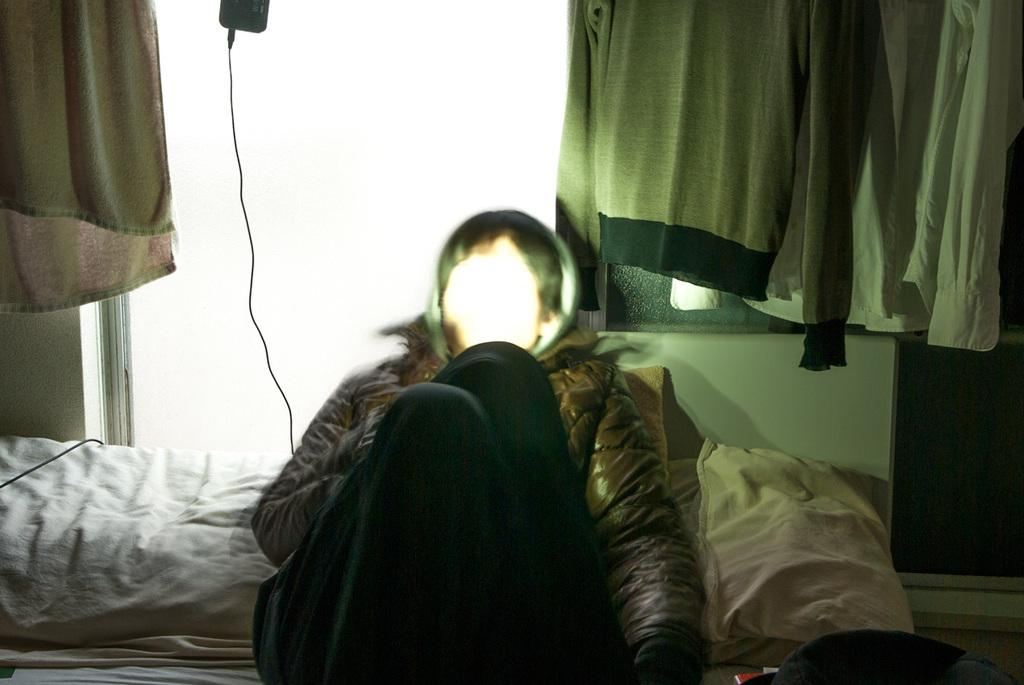What is the main subject of the image? There is a person sleeping on a bed in the image. What is supporting the person's back while they sleep? The person has a pillow behind their back. What can be seen in the background of the image? There are shirts, a wall, a wire, and cloth in the background of the image. What type of eyes can be seen on the turkey in the image? There is no turkey present in the image; it features a person sleeping on a bed with a pillow behind their back and various items in the background. What is the person using to rake leaves in the image? There is no rake or leaves present in the image; it focuses on a person sleeping on a bed with a pillow behind their back and the background elements. 